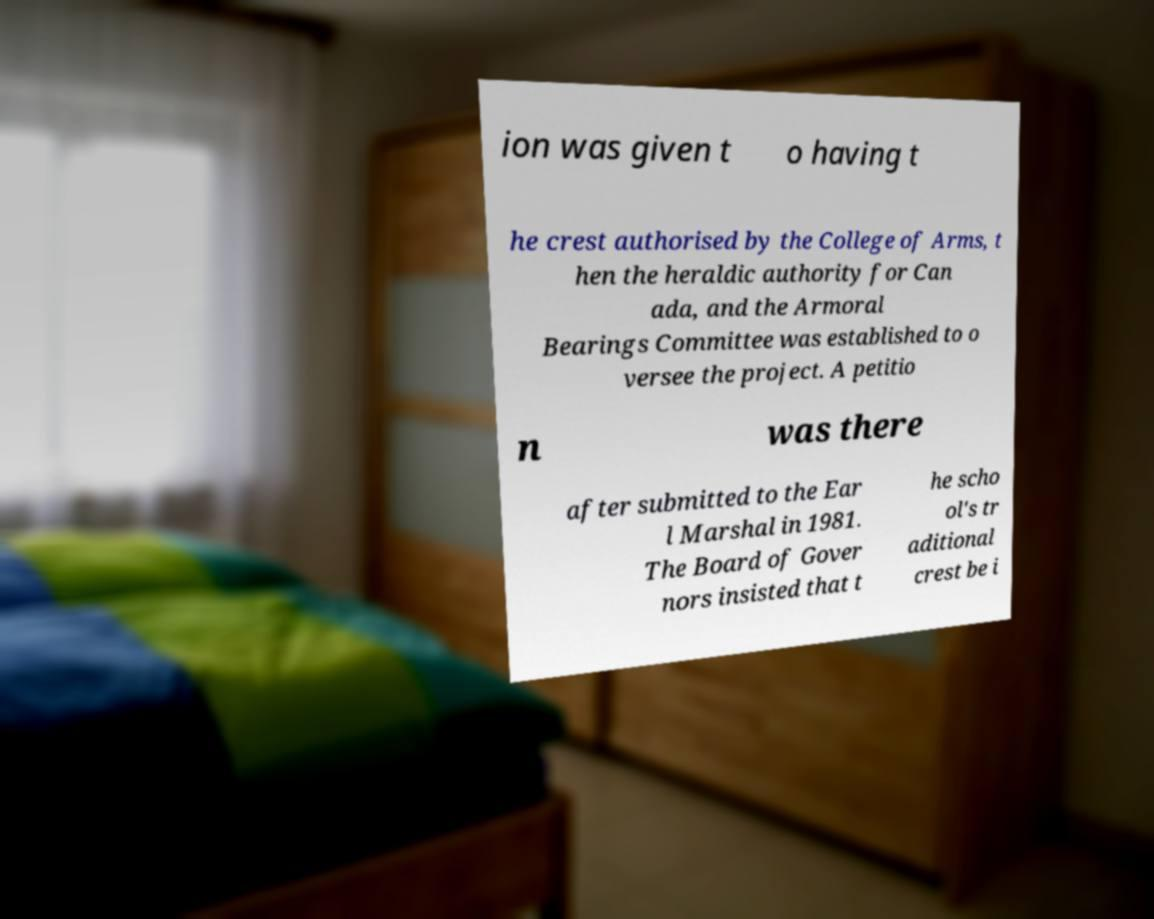Can you accurately transcribe the text from the provided image for me? ion was given t o having t he crest authorised by the College of Arms, t hen the heraldic authority for Can ada, and the Armoral Bearings Committee was established to o versee the project. A petitio n was there after submitted to the Ear l Marshal in 1981. The Board of Gover nors insisted that t he scho ol's tr aditional crest be i 